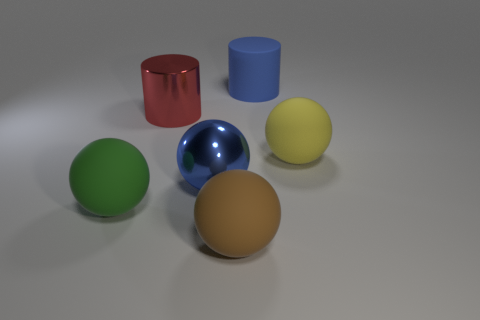How many brown spheres are left of the metal thing in front of the big yellow object?
Provide a succinct answer. 0. What number of matte things are left of the blue metallic ball and on the right side of the green matte object?
Give a very brief answer. 0. How many objects are matte spheres to the left of the metallic cylinder or large matte things left of the large brown thing?
Make the answer very short. 1. What number of other objects are the same size as the yellow rubber object?
Offer a very short reply. 5. There is a blue object in front of the ball right of the brown sphere; what shape is it?
Offer a terse response. Sphere. Is the color of the big cylinder to the right of the brown sphere the same as the large metal object that is in front of the big red metallic cylinder?
Your response must be concise. Yes. Is there anything else of the same color as the metallic cylinder?
Keep it short and to the point. No. What color is the matte cylinder?
Your response must be concise. Blue. Are any gray blocks visible?
Provide a succinct answer. No. There is a green rubber object; are there any large blue balls right of it?
Your answer should be compact. Yes. 